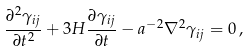Convert formula to latex. <formula><loc_0><loc_0><loc_500><loc_500>\frac { \partial ^ { 2 } \gamma _ { i j } } { \partial t ^ { 2 } } + 3 H \frac { \partial \gamma _ { i j } } { \partial t } - a ^ { - 2 } \nabla ^ { 2 } \gamma _ { i j } = 0 \, ,</formula> 